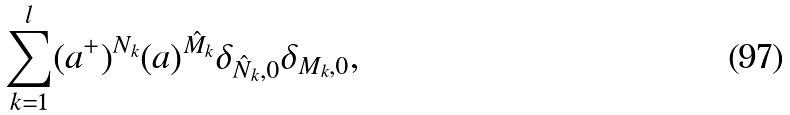<formula> <loc_0><loc_0><loc_500><loc_500>\sum _ { k = 1 } ^ { l } ( a ^ { + } ) ^ { N _ { k } } ( a ) ^ { \hat { M } _ { k } } \delta _ { \hat { N } _ { k } , 0 } \delta _ { M _ { k } , 0 } ,</formula> 